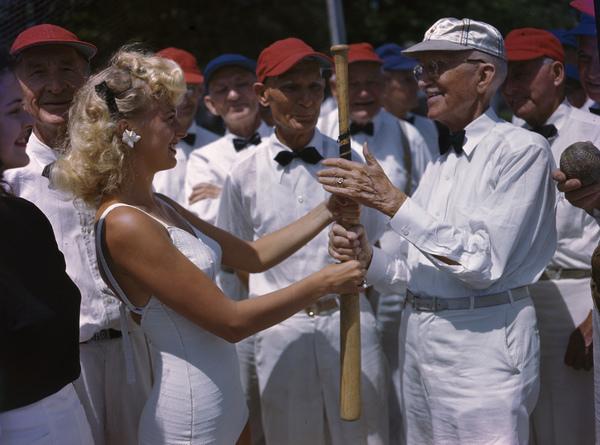What type of contest is this?
Answer briefly. Baseball. Who is the blonde lady?
Quick response, please. Marilyn monroe. What is the predominant clothing color?
Concise answer only. White. 